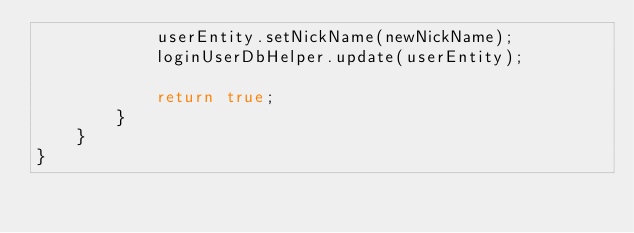Convert code to text. <code><loc_0><loc_0><loc_500><loc_500><_Java_>            userEntity.setNickName(newNickName);
            loginUserDbHelper.update(userEntity);

            return true;
        }
    }
}
</code> 